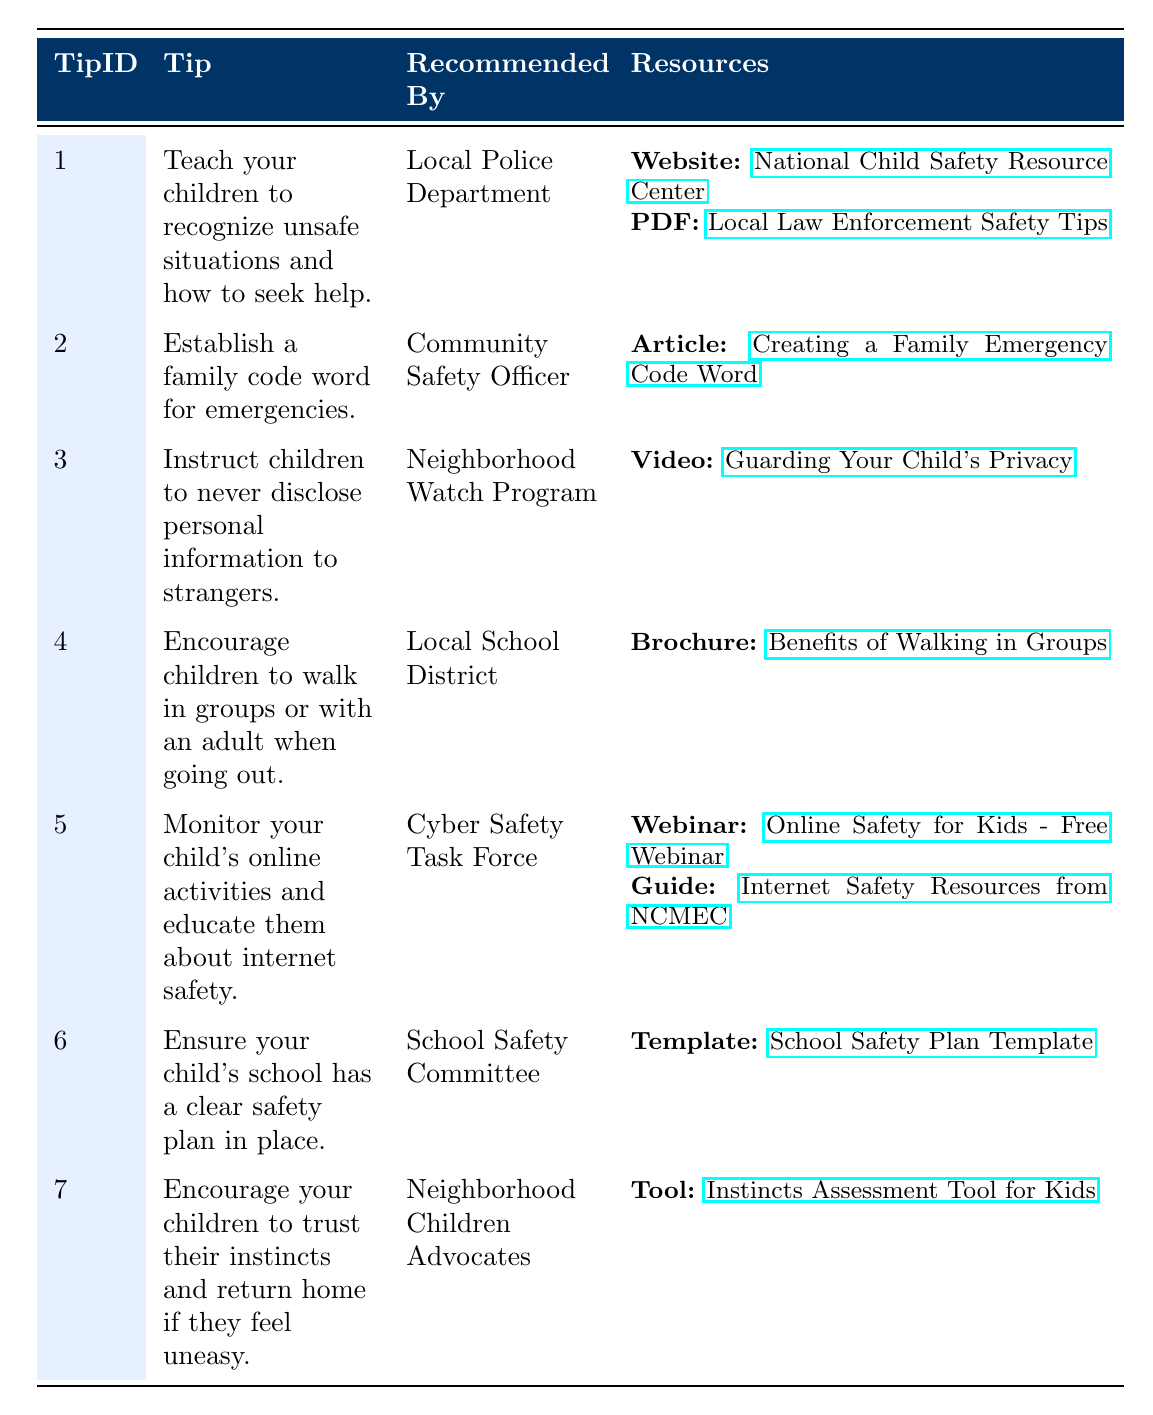What is the tip recommended by the Local Police Department? The table shows that the tip recommended by the Local Police Department is "Teach your children to recognize unsafe situations and how to seek help." This can be directly retrieved from the corresponding row in the table.
Answer: Teach your children to recognize unsafe situations and how to seek help How many resources are recommended for the tip about monitoring online activities? In the row for the tip about monitoring children's online activities, there are two resources listed: a webinar and a guide. We can count both to get the total resources recommended for this tip.
Answer: 2 Is there a tip that advises children to walk in groups? Yes, there is a tip that advises children to walk in groups or with an adult when going out. This is verified by looking for the specific wording in the table.
Answer: Yes What types of resources are provided for the tip related to establishing a family code word? The table indicates that for the tip about establishing a family code word, there is one resource, which is an article. We can confirm this by checking the corresponding resources column of this tip in the table.
Answer: Article Which organization recommends educating children about online safety? The Cyber Safety Task Force recommends educating children about online safety. This information can be confirmed by checking the "Recommended By" column for the relevant tip in the table.
Answer: Cyber Safety Task Force How many tips are recommended by the Neighborhood Watch Program? The table shows that one tip is recommended by the Neighborhood Watch Program, specifically related to instructing children not to disclose personal information to strangers. By scanning the "Recommended By" column, we confirm this.
Answer: 1 List the resources available for the tip encouraging trust in instincts. The resources for the tip encouraging children to trust their instincts include one tool, specifically the "Instincts Assessment Tool for Kids." This is found in the corresponding resources section of the row.
Answer: 1 Tool What is required to ensure a child's school has a clear safety plan? The table specifies that the School Safety Committee recommends ensuring that a child's school has a clear safety plan in place. By referencing the relevant row, we can retrieve this information.
Answer: Ensure a clear safety plan is in place Identify the organization responsible for providing a template for a school safety plan. The School Safety Committee is responsible for providing a template for a school safety plan. We can verify this through the "Recommended By" column in the table.
Answer: School Safety Committee 